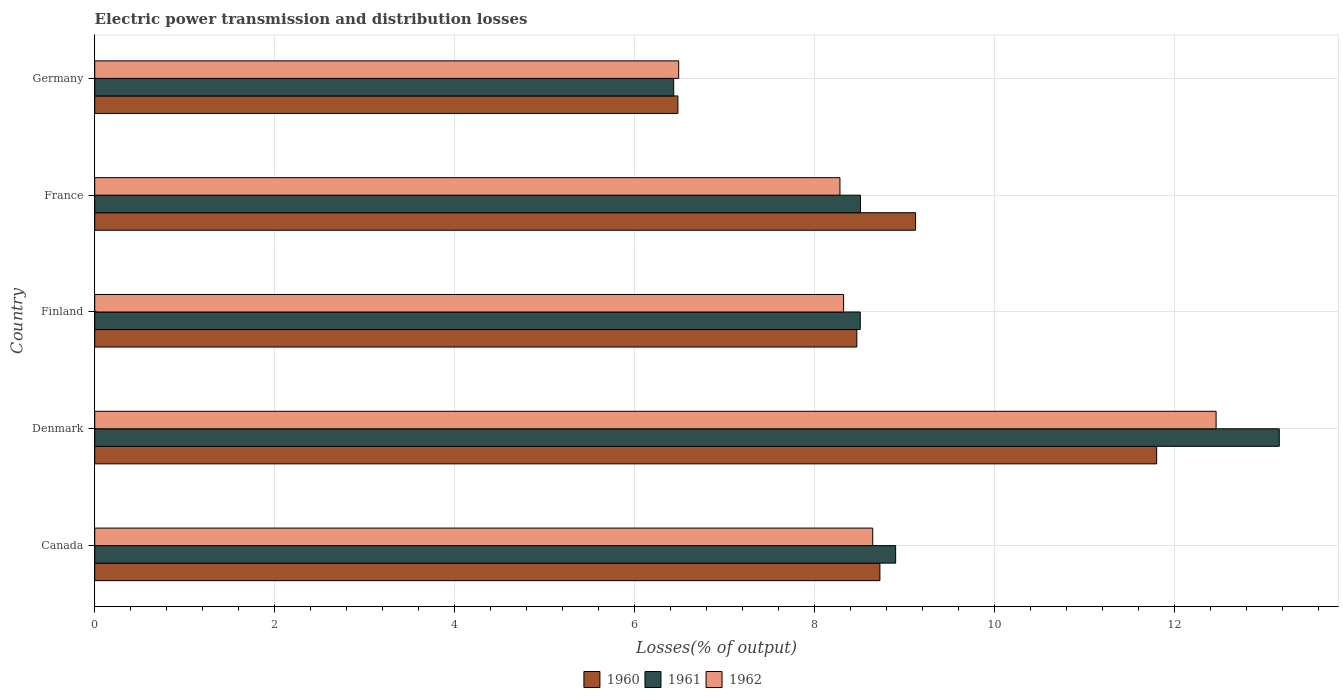How many different coloured bars are there?
Offer a terse response. 3. Are the number of bars per tick equal to the number of legend labels?
Ensure brevity in your answer.  Yes. Are the number of bars on each tick of the Y-axis equal?
Your response must be concise. Yes. How many bars are there on the 3rd tick from the bottom?
Your answer should be very brief. 3. In how many cases, is the number of bars for a given country not equal to the number of legend labels?
Provide a short and direct response. 0. What is the electric power transmission and distribution losses in 1962 in France?
Make the answer very short. 8.28. Across all countries, what is the maximum electric power transmission and distribution losses in 1962?
Your response must be concise. 12.47. Across all countries, what is the minimum electric power transmission and distribution losses in 1960?
Provide a short and direct response. 6.48. In which country was the electric power transmission and distribution losses in 1962 maximum?
Your answer should be compact. Denmark. In which country was the electric power transmission and distribution losses in 1961 minimum?
Ensure brevity in your answer.  Germany. What is the total electric power transmission and distribution losses in 1962 in the graph?
Your answer should be compact. 44.21. What is the difference between the electric power transmission and distribution losses in 1960 in Canada and that in Denmark?
Your answer should be very brief. -3.08. What is the difference between the electric power transmission and distribution losses in 1961 in Canada and the electric power transmission and distribution losses in 1962 in France?
Your answer should be very brief. 0.62. What is the average electric power transmission and distribution losses in 1961 per country?
Offer a terse response. 9.11. What is the difference between the electric power transmission and distribution losses in 1961 and electric power transmission and distribution losses in 1960 in Germany?
Your answer should be very brief. -0.05. In how many countries, is the electric power transmission and distribution losses in 1960 greater than 3.2 %?
Ensure brevity in your answer.  5. What is the ratio of the electric power transmission and distribution losses in 1962 in Canada to that in Finland?
Offer a very short reply. 1.04. Is the electric power transmission and distribution losses in 1961 in Canada less than that in Denmark?
Your answer should be compact. Yes. What is the difference between the highest and the second highest electric power transmission and distribution losses in 1960?
Provide a succinct answer. 2.68. What is the difference between the highest and the lowest electric power transmission and distribution losses in 1960?
Provide a short and direct response. 5.32. Is the sum of the electric power transmission and distribution losses in 1961 in Canada and Germany greater than the maximum electric power transmission and distribution losses in 1962 across all countries?
Provide a succinct answer. Yes. What does the 3rd bar from the top in Denmark represents?
Offer a very short reply. 1960. Is it the case that in every country, the sum of the electric power transmission and distribution losses in 1960 and electric power transmission and distribution losses in 1961 is greater than the electric power transmission and distribution losses in 1962?
Your answer should be compact. Yes. How many bars are there?
Keep it short and to the point. 15. How many countries are there in the graph?
Provide a succinct answer. 5. What is the difference between two consecutive major ticks on the X-axis?
Provide a succinct answer. 2. Does the graph contain any zero values?
Provide a short and direct response. No. Does the graph contain grids?
Your response must be concise. Yes. What is the title of the graph?
Your answer should be very brief. Electric power transmission and distribution losses. What is the label or title of the X-axis?
Make the answer very short. Losses(% of output). What is the label or title of the Y-axis?
Provide a short and direct response. Country. What is the Losses(% of output) of 1960 in Canada?
Ensure brevity in your answer.  8.73. What is the Losses(% of output) in 1961 in Canada?
Ensure brevity in your answer.  8.9. What is the Losses(% of output) in 1962 in Canada?
Provide a succinct answer. 8.65. What is the Losses(% of output) of 1960 in Denmark?
Make the answer very short. 11.81. What is the Losses(% of output) of 1961 in Denmark?
Your answer should be very brief. 13.17. What is the Losses(% of output) in 1962 in Denmark?
Provide a succinct answer. 12.47. What is the Losses(% of output) in 1960 in Finland?
Your answer should be very brief. 8.47. What is the Losses(% of output) in 1961 in Finland?
Your response must be concise. 8.51. What is the Losses(% of output) of 1962 in Finland?
Your answer should be very brief. 8.32. What is the Losses(% of output) in 1960 in France?
Make the answer very short. 9.12. What is the Losses(% of output) in 1961 in France?
Make the answer very short. 8.51. What is the Losses(% of output) of 1962 in France?
Your response must be concise. 8.28. What is the Losses(% of output) in 1960 in Germany?
Ensure brevity in your answer.  6.48. What is the Losses(% of output) in 1961 in Germany?
Provide a short and direct response. 6.44. What is the Losses(% of output) in 1962 in Germany?
Your answer should be very brief. 6.49. Across all countries, what is the maximum Losses(% of output) in 1960?
Offer a terse response. 11.81. Across all countries, what is the maximum Losses(% of output) in 1961?
Give a very brief answer. 13.17. Across all countries, what is the maximum Losses(% of output) of 1962?
Give a very brief answer. 12.47. Across all countries, what is the minimum Losses(% of output) in 1960?
Offer a very short reply. 6.48. Across all countries, what is the minimum Losses(% of output) of 1961?
Offer a very short reply. 6.44. Across all countries, what is the minimum Losses(% of output) of 1962?
Make the answer very short. 6.49. What is the total Losses(% of output) in 1960 in the graph?
Make the answer very short. 44.61. What is the total Losses(% of output) of 1961 in the graph?
Make the answer very short. 45.53. What is the total Losses(% of output) of 1962 in the graph?
Your answer should be very brief. 44.21. What is the difference between the Losses(% of output) in 1960 in Canada and that in Denmark?
Your response must be concise. -3.08. What is the difference between the Losses(% of output) of 1961 in Canada and that in Denmark?
Ensure brevity in your answer.  -4.26. What is the difference between the Losses(% of output) of 1962 in Canada and that in Denmark?
Your response must be concise. -3.82. What is the difference between the Losses(% of output) of 1960 in Canada and that in Finland?
Keep it short and to the point. 0.26. What is the difference between the Losses(% of output) of 1961 in Canada and that in Finland?
Provide a short and direct response. 0.39. What is the difference between the Losses(% of output) in 1962 in Canada and that in Finland?
Your answer should be very brief. 0.32. What is the difference between the Losses(% of output) in 1960 in Canada and that in France?
Make the answer very short. -0.4. What is the difference between the Losses(% of output) in 1961 in Canada and that in France?
Make the answer very short. 0.39. What is the difference between the Losses(% of output) of 1962 in Canada and that in France?
Offer a terse response. 0.36. What is the difference between the Losses(% of output) in 1960 in Canada and that in Germany?
Provide a short and direct response. 2.25. What is the difference between the Losses(% of output) in 1961 in Canada and that in Germany?
Provide a short and direct response. 2.47. What is the difference between the Losses(% of output) of 1962 in Canada and that in Germany?
Your response must be concise. 2.16. What is the difference between the Losses(% of output) in 1960 in Denmark and that in Finland?
Make the answer very short. 3.33. What is the difference between the Losses(% of output) of 1961 in Denmark and that in Finland?
Offer a very short reply. 4.66. What is the difference between the Losses(% of output) in 1962 in Denmark and that in Finland?
Provide a succinct answer. 4.14. What is the difference between the Losses(% of output) in 1960 in Denmark and that in France?
Provide a succinct answer. 2.68. What is the difference between the Losses(% of output) in 1961 in Denmark and that in France?
Provide a succinct answer. 4.66. What is the difference between the Losses(% of output) of 1962 in Denmark and that in France?
Make the answer very short. 4.18. What is the difference between the Losses(% of output) of 1960 in Denmark and that in Germany?
Offer a terse response. 5.32. What is the difference between the Losses(% of output) of 1961 in Denmark and that in Germany?
Keep it short and to the point. 6.73. What is the difference between the Losses(% of output) in 1962 in Denmark and that in Germany?
Keep it short and to the point. 5.97. What is the difference between the Losses(% of output) in 1960 in Finland and that in France?
Provide a succinct answer. -0.65. What is the difference between the Losses(% of output) in 1961 in Finland and that in France?
Provide a short and direct response. -0. What is the difference between the Losses(% of output) of 1962 in Finland and that in France?
Offer a terse response. 0.04. What is the difference between the Losses(% of output) in 1960 in Finland and that in Germany?
Offer a terse response. 1.99. What is the difference between the Losses(% of output) in 1961 in Finland and that in Germany?
Make the answer very short. 2.07. What is the difference between the Losses(% of output) in 1962 in Finland and that in Germany?
Your answer should be very brief. 1.83. What is the difference between the Losses(% of output) in 1960 in France and that in Germany?
Offer a very short reply. 2.64. What is the difference between the Losses(% of output) of 1961 in France and that in Germany?
Your answer should be compact. 2.08. What is the difference between the Losses(% of output) in 1962 in France and that in Germany?
Ensure brevity in your answer.  1.79. What is the difference between the Losses(% of output) of 1960 in Canada and the Losses(% of output) of 1961 in Denmark?
Keep it short and to the point. -4.44. What is the difference between the Losses(% of output) of 1960 in Canada and the Losses(% of output) of 1962 in Denmark?
Provide a succinct answer. -3.74. What is the difference between the Losses(% of output) of 1961 in Canada and the Losses(% of output) of 1962 in Denmark?
Your answer should be very brief. -3.56. What is the difference between the Losses(% of output) of 1960 in Canada and the Losses(% of output) of 1961 in Finland?
Your response must be concise. 0.22. What is the difference between the Losses(% of output) in 1960 in Canada and the Losses(% of output) in 1962 in Finland?
Your response must be concise. 0.4. What is the difference between the Losses(% of output) in 1961 in Canada and the Losses(% of output) in 1962 in Finland?
Offer a terse response. 0.58. What is the difference between the Losses(% of output) in 1960 in Canada and the Losses(% of output) in 1961 in France?
Provide a short and direct response. 0.22. What is the difference between the Losses(% of output) in 1960 in Canada and the Losses(% of output) in 1962 in France?
Make the answer very short. 0.44. What is the difference between the Losses(% of output) of 1961 in Canada and the Losses(% of output) of 1962 in France?
Give a very brief answer. 0.62. What is the difference between the Losses(% of output) of 1960 in Canada and the Losses(% of output) of 1961 in Germany?
Give a very brief answer. 2.29. What is the difference between the Losses(% of output) of 1960 in Canada and the Losses(% of output) of 1962 in Germany?
Your response must be concise. 2.24. What is the difference between the Losses(% of output) of 1961 in Canada and the Losses(% of output) of 1962 in Germany?
Keep it short and to the point. 2.41. What is the difference between the Losses(% of output) in 1960 in Denmark and the Losses(% of output) in 1961 in Finland?
Your answer should be compact. 3.29. What is the difference between the Losses(% of output) of 1960 in Denmark and the Losses(% of output) of 1962 in Finland?
Provide a short and direct response. 3.48. What is the difference between the Losses(% of output) in 1961 in Denmark and the Losses(% of output) in 1962 in Finland?
Your answer should be very brief. 4.84. What is the difference between the Losses(% of output) of 1960 in Denmark and the Losses(% of output) of 1961 in France?
Offer a very short reply. 3.29. What is the difference between the Losses(% of output) in 1960 in Denmark and the Losses(% of output) in 1962 in France?
Offer a very short reply. 3.52. What is the difference between the Losses(% of output) in 1961 in Denmark and the Losses(% of output) in 1962 in France?
Your answer should be very brief. 4.88. What is the difference between the Losses(% of output) in 1960 in Denmark and the Losses(% of output) in 1961 in Germany?
Offer a terse response. 5.37. What is the difference between the Losses(% of output) of 1960 in Denmark and the Losses(% of output) of 1962 in Germany?
Your answer should be compact. 5.31. What is the difference between the Losses(% of output) in 1961 in Denmark and the Losses(% of output) in 1962 in Germany?
Ensure brevity in your answer.  6.68. What is the difference between the Losses(% of output) of 1960 in Finland and the Losses(% of output) of 1961 in France?
Keep it short and to the point. -0.04. What is the difference between the Losses(% of output) in 1960 in Finland and the Losses(% of output) in 1962 in France?
Give a very brief answer. 0.19. What is the difference between the Losses(% of output) in 1961 in Finland and the Losses(% of output) in 1962 in France?
Ensure brevity in your answer.  0.23. What is the difference between the Losses(% of output) of 1960 in Finland and the Losses(% of output) of 1961 in Germany?
Provide a short and direct response. 2.04. What is the difference between the Losses(% of output) of 1960 in Finland and the Losses(% of output) of 1962 in Germany?
Offer a terse response. 1.98. What is the difference between the Losses(% of output) of 1961 in Finland and the Losses(% of output) of 1962 in Germany?
Make the answer very short. 2.02. What is the difference between the Losses(% of output) in 1960 in France and the Losses(% of output) in 1961 in Germany?
Your response must be concise. 2.69. What is the difference between the Losses(% of output) of 1960 in France and the Losses(% of output) of 1962 in Germany?
Give a very brief answer. 2.63. What is the difference between the Losses(% of output) in 1961 in France and the Losses(% of output) in 1962 in Germany?
Your answer should be compact. 2.02. What is the average Losses(% of output) in 1960 per country?
Provide a succinct answer. 8.92. What is the average Losses(% of output) of 1961 per country?
Provide a short and direct response. 9.11. What is the average Losses(% of output) of 1962 per country?
Provide a short and direct response. 8.84. What is the difference between the Losses(% of output) in 1960 and Losses(% of output) in 1961 in Canada?
Offer a terse response. -0.17. What is the difference between the Losses(% of output) in 1961 and Losses(% of output) in 1962 in Canada?
Provide a succinct answer. 0.25. What is the difference between the Losses(% of output) in 1960 and Losses(% of output) in 1961 in Denmark?
Your response must be concise. -1.36. What is the difference between the Losses(% of output) of 1960 and Losses(% of output) of 1962 in Denmark?
Provide a short and direct response. -0.66. What is the difference between the Losses(% of output) of 1961 and Losses(% of output) of 1962 in Denmark?
Offer a terse response. 0.7. What is the difference between the Losses(% of output) in 1960 and Losses(% of output) in 1961 in Finland?
Provide a short and direct response. -0.04. What is the difference between the Losses(% of output) of 1960 and Losses(% of output) of 1962 in Finland?
Offer a terse response. 0.15. What is the difference between the Losses(% of output) in 1961 and Losses(% of output) in 1962 in Finland?
Ensure brevity in your answer.  0.19. What is the difference between the Losses(% of output) in 1960 and Losses(% of output) in 1961 in France?
Offer a very short reply. 0.61. What is the difference between the Losses(% of output) in 1960 and Losses(% of output) in 1962 in France?
Your response must be concise. 0.84. What is the difference between the Losses(% of output) of 1961 and Losses(% of output) of 1962 in France?
Your answer should be very brief. 0.23. What is the difference between the Losses(% of output) in 1960 and Losses(% of output) in 1961 in Germany?
Make the answer very short. 0.05. What is the difference between the Losses(% of output) of 1960 and Losses(% of output) of 1962 in Germany?
Offer a very short reply. -0.01. What is the difference between the Losses(% of output) of 1961 and Losses(% of output) of 1962 in Germany?
Your answer should be compact. -0.06. What is the ratio of the Losses(% of output) in 1960 in Canada to that in Denmark?
Offer a terse response. 0.74. What is the ratio of the Losses(% of output) of 1961 in Canada to that in Denmark?
Your answer should be very brief. 0.68. What is the ratio of the Losses(% of output) in 1962 in Canada to that in Denmark?
Your answer should be compact. 0.69. What is the ratio of the Losses(% of output) of 1960 in Canada to that in Finland?
Make the answer very short. 1.03. What is the ratio of the Losses(% of output) of 1961 in Canada to that in Finland?
Provide a short and direct response. 1.05. What is the ratio of the Losses(% of output) of 1962 in Canada to that in Finland?
Your response must be concise. 1.04. What is the ratio of the Losses(% of output) in 1960 in Canada to that in France?
Ensure brevity in your answer.  0.96. What is the ratio of the Losses(% of output) in 1961 in Canada to that in France?
Make the answer very short. 1.05. What is the ratio of the Losses(% of output) in 1962 in Canada to that in France?
Your response must be concise. 1.04. What is the ratio of the Losses(% of output) in 1960 in Canada to that in Germany?
Your answer should be very brief. 1.35. What is the ratio of the Losses(% of output) in 1961 in Canada to that in Germany?
Offer a terse response. 1.38. What is the ratio of the Losses(% of output) of 1962 in Canada to that in Germany?
Provide a short and direct response. 1.33. What is the ratio of the Losses(% of output) in 1960 in Denmark to that in Finland?
Your response must be concise. 1.39. What is the ratio of the Losses(% of output) of 1961 in Denmark to that in Finland?
Provide a short and direct response. 1.55. What is the ratio of the Losses(% of output) of 1962 in Denmark to that in Finland?
Provide a short and direct response. 1.5. What is the ratio of the Losses(% of output) in 1960 in Denmark to that in France?
Provide a short and direct response. 1.29. What is the ratio of the Losses(% of output) in 1961 in Denmark to that in France?
Ensure brevity in your answer.  1.55. What is the ratio of the Losses(% of output) in 1962 in Denmark to that in France?
Your answer should be compact. 1.5. What is the ratio of the Losses(% of output) in 1960 in Denmark to that in Germany?
Provide a succinct answer. 1.82. What is the ratio of the Losses(% of output) of 1961 in Denmark to that in Germany?
Make the answer very short. 2.05. What is the ratio of the Losses(% of output) of 1962 in Denmark to that in Germany?
Your answer should be compact. 1.92. What is the ratio of the Losses(% of output) of 1960 in Finland to that in France?
Your answer should be compact. 0.93. What is the ratio of the Losses(% of output) in 1961 in Finland to that in France?
Provide a succinct answer. 1. What is the ratio of the Losses(% of output) in 1960 in Finland to that in Germany?
Offer a very short reply. 1.31. What is the ratio of the Losses(% of output) of 1961 in Finland to that in Germany?
Your answer should be very brief. 1.32. What is the ratio of the Losses(% of output) in 1962 in Finland to that in Germany?
Ensure brevity in your answer.  1.28. What is the ratio of the Losses(% of output) of 1960 in France to that in Germany?
Your answer should be very brief. 1.41. What is the ratio of the Losses(% of output) in 1961 in France to that in Germany?
Give a very brief answer. 1.32. What is the ratio of the Losses(% of output) in 1962 in France to that in Germany?
Offer a very short reply. 1.28. What is the difference between the highest and the second highest Losses(% of output) in 1960?
Keep it short and to the point. 2.68. What is the difference between the highest and the second highest Losses(% of output) of 1961?
Give a very brief answer. 4.26. What is the difference between the highest and the second highest Losses(% of output) of 1962?
Your answer should be compact. 3.82. What is the difference between the highest and the lowest Losses(% of output) in 1960?
Your response must be concise. 5.32. What is the difference between the highest and the lowest Losses(% of output) in 1961?
Provide a succinct answer. 6.73. What is the difference between the highest and the lowest Losses(% of output) of 1962?
Make the answer very short. 5.97. 